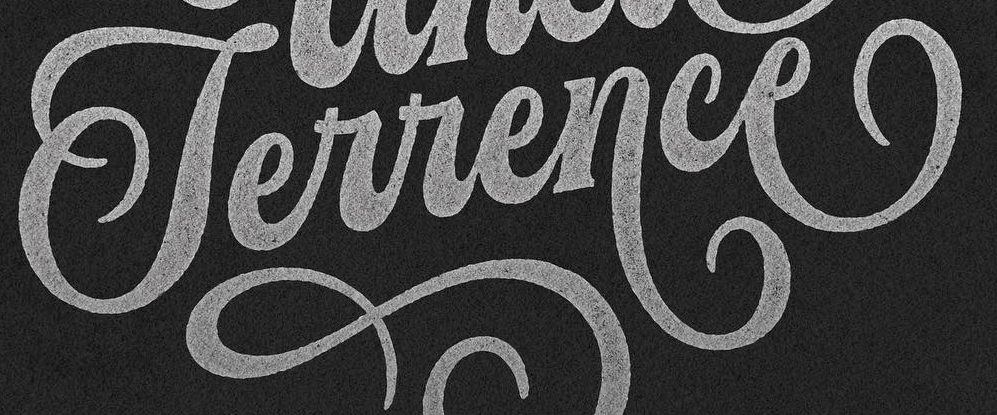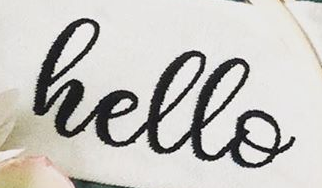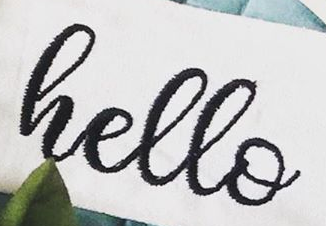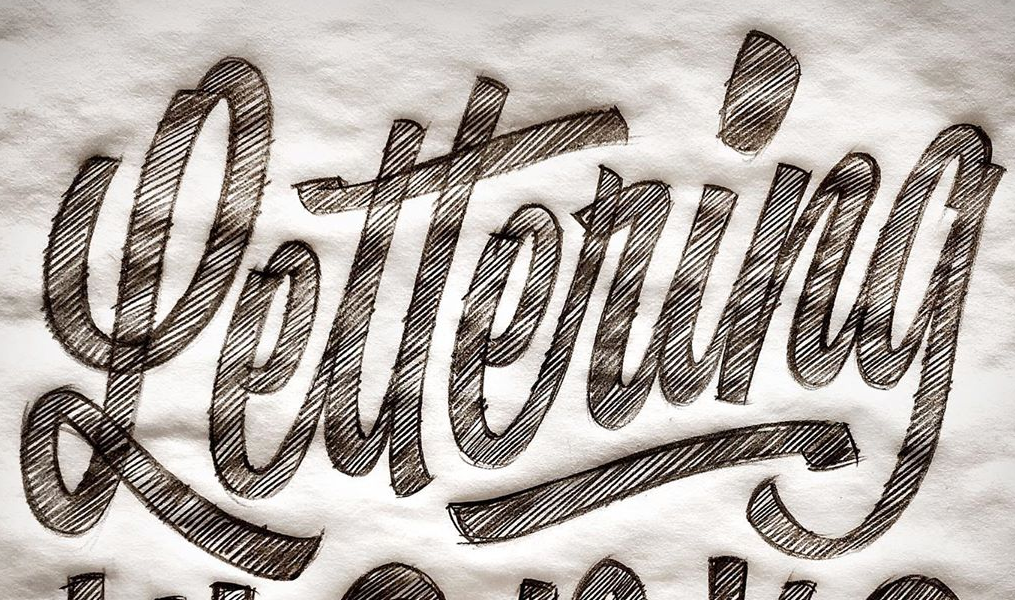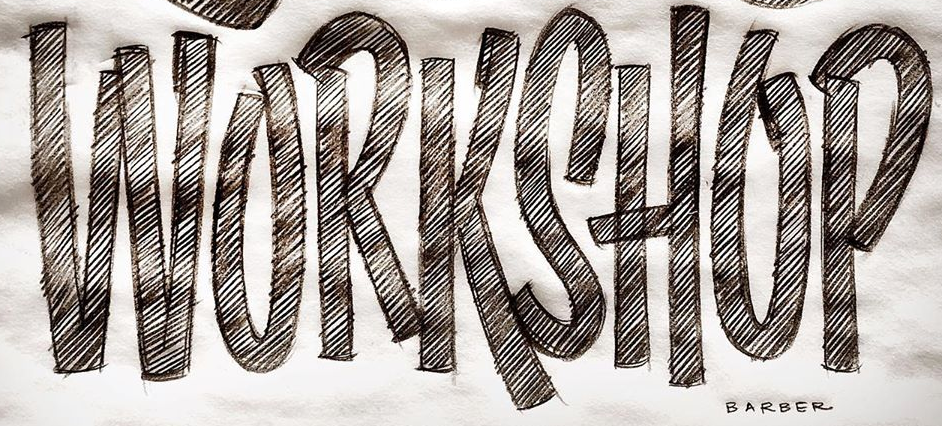What text appears in these images from left to right, separated by a semicolon? Terrence; hello; hello; Lettering; WORKSHOP 